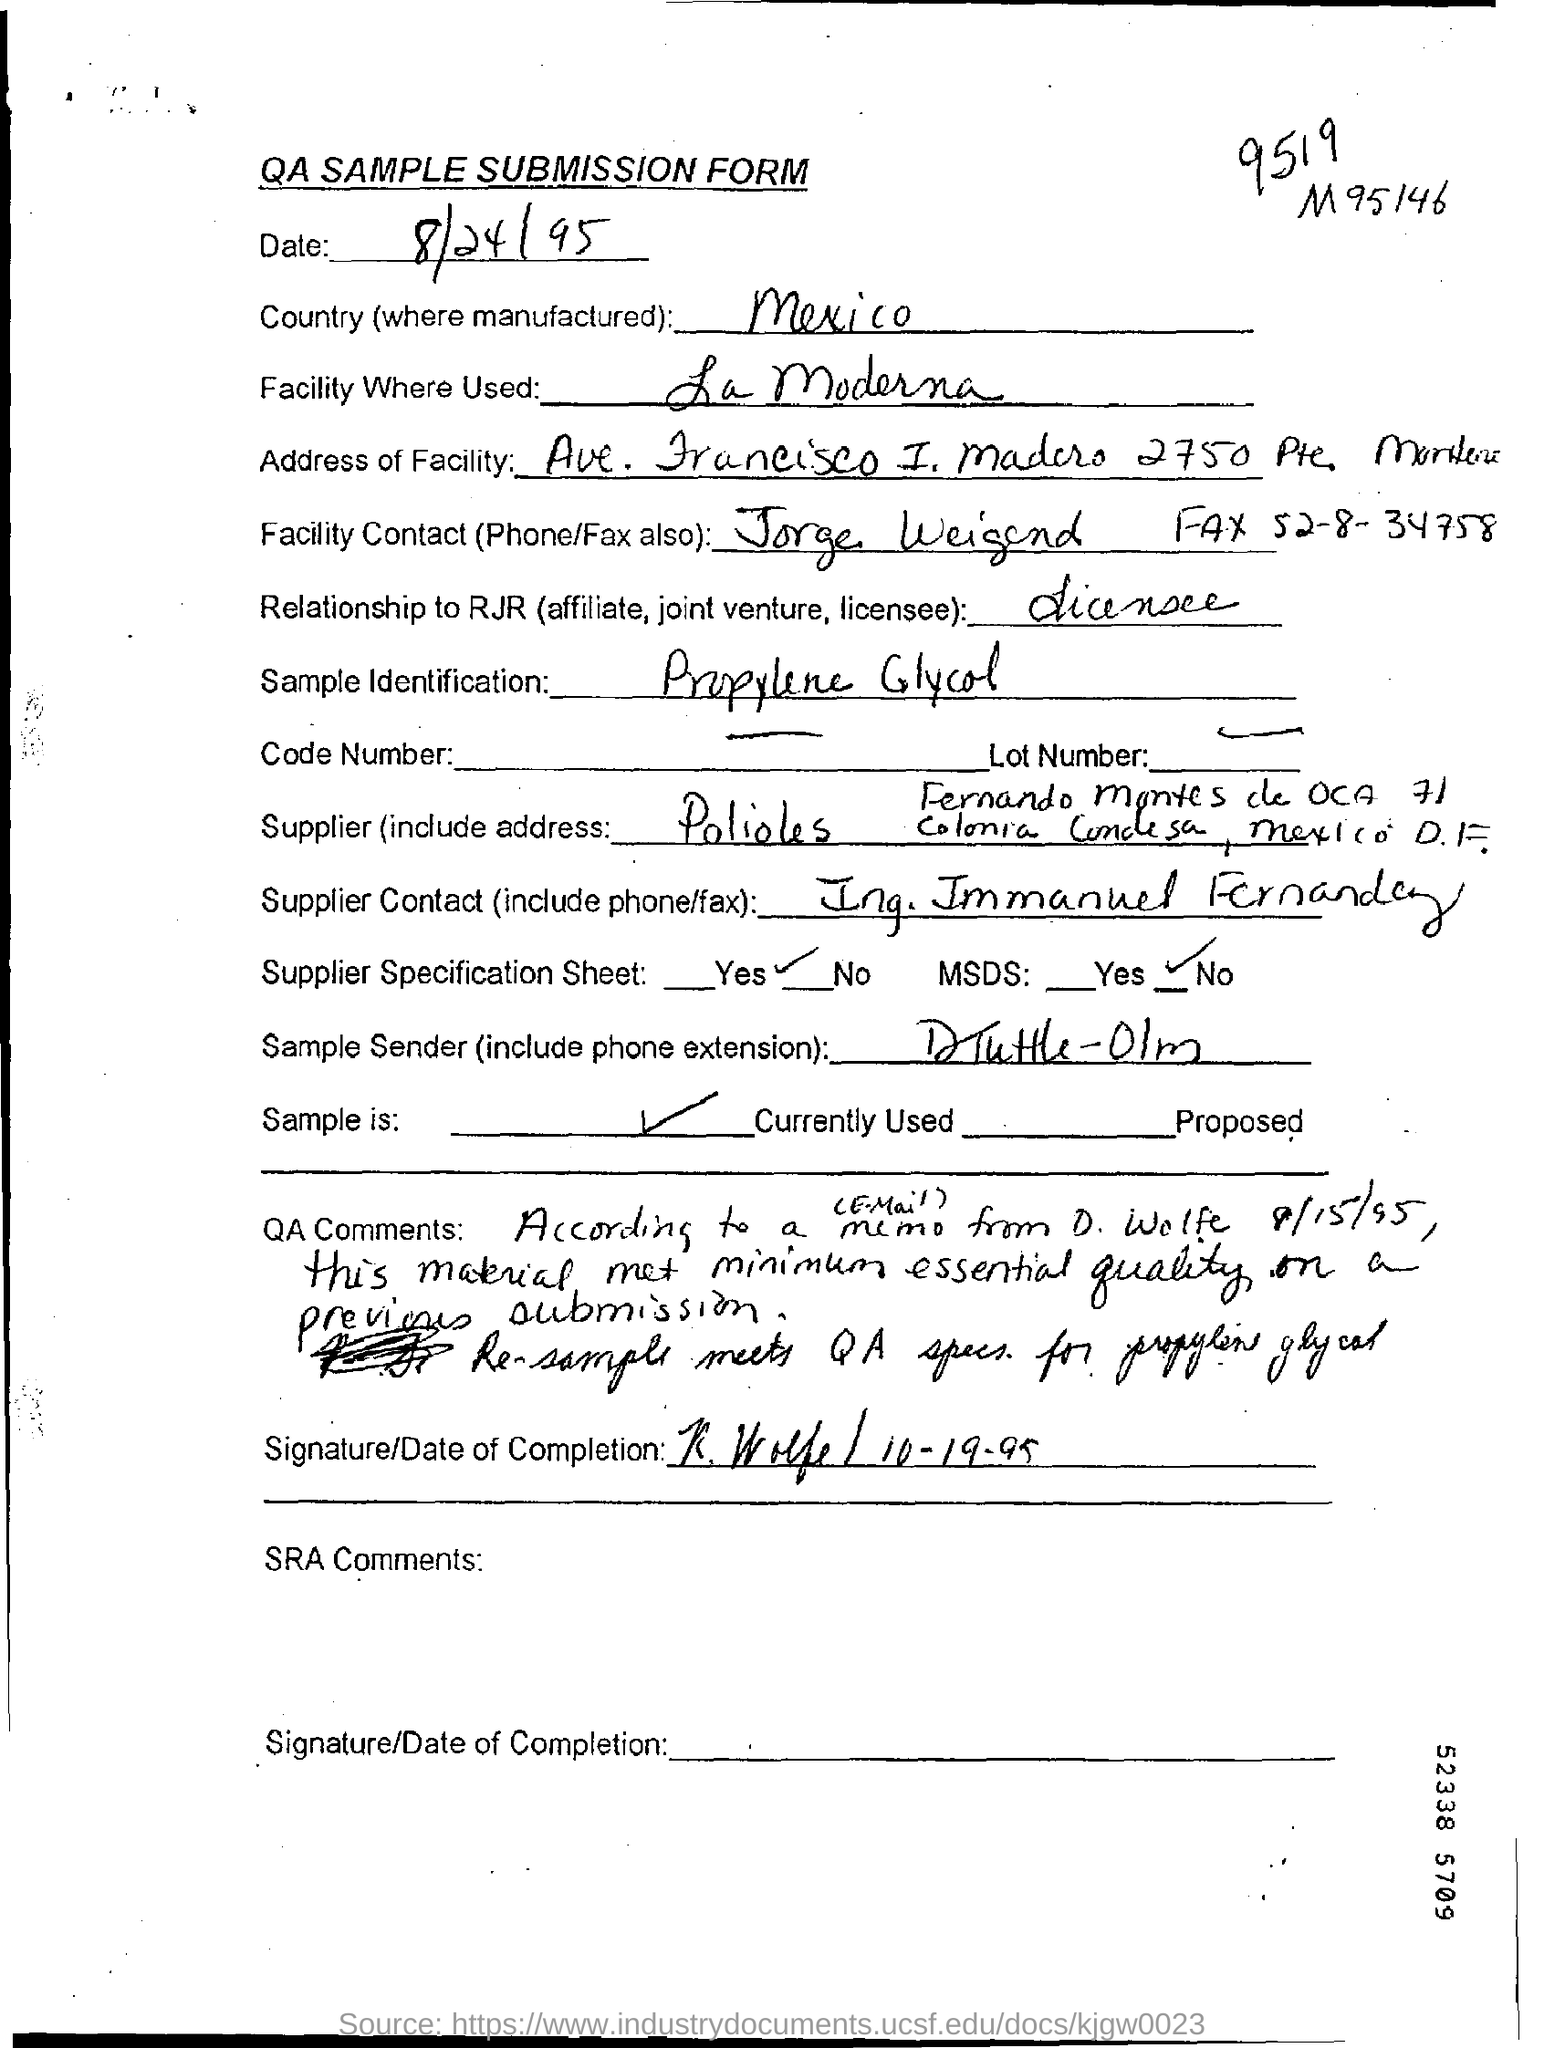What is the heading of the document?
Your response must be concise. QA SAMPLE SUBMISSION FORM. Which year does this document dates back to?
Offer a terse response. 95. What is the Country mentioned?
Make the answer very short. Mexico. What is the Sample Identification?
Give a very brief answer. Propylene Glycol. 